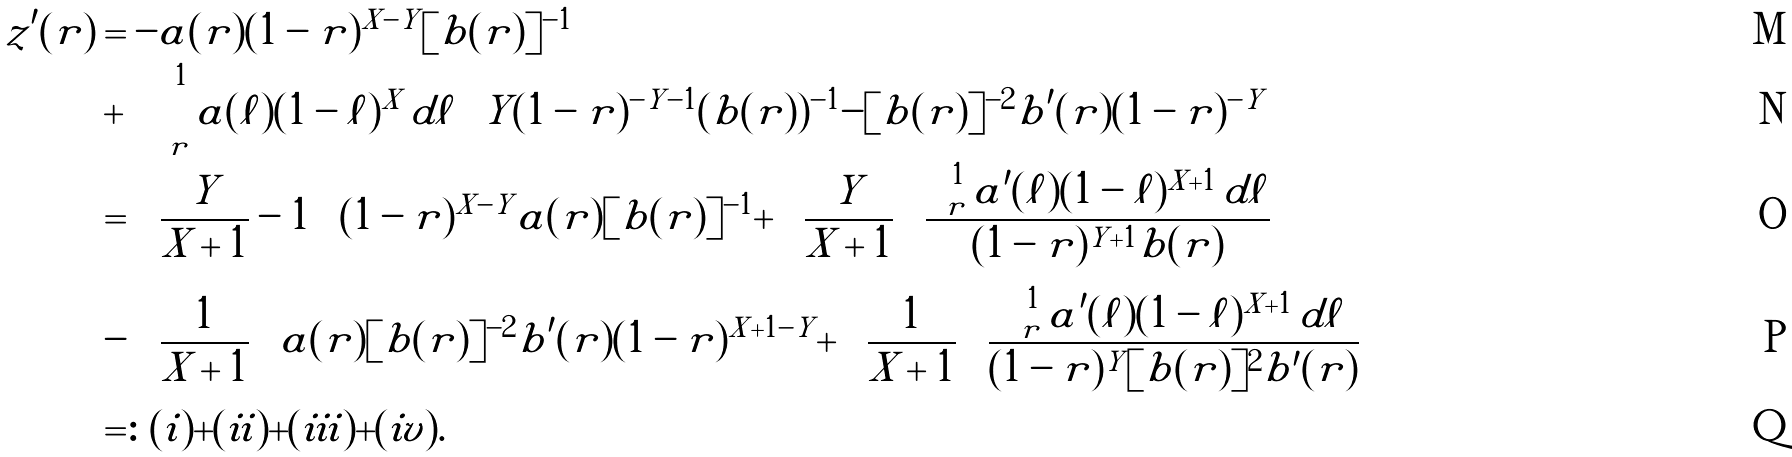<formula> <loc_0><loc_0><loc_500><loc_500>z ^ { \prime } ( r ) & = - a ( r ) ( 1 - r ) ^ { X - Y } [ b ( r ) ] ^ { - 1 } \\ & + \int _ { r } ^ { 1 } a ( \ell ) ( 1 - \ell ) ^ { X } \, d \ell \left [ Y ( 1 - r ) ^ { - Y - 1 } ( b ( r ) ) ^ { - 1 } - [ b ( r ) ] ^ { - 2 } b ^ { \prime } ( r ) ( 1 - r ) ^ { - Y } \right ] \\ & = \left ( \frac { Y } { X + 1 } - 1 \right ) ( 1 - r ) ^ { X - Y } a ( r ) [ b ( r ) ] ^ { - 1 } + \left ( \frac { Y } { X + 1 } \right ) \frac { \int _ { r } ^ { 1 } a ^ { \prime } ( \ell ) ( 1 - \ell ) ^ { X + 1 } \, d \ell } { ( 1 - r ) ^ { Y + 1 } b ( r ) } \\ & - \left ( \frac { 1 } { X + 1 } \right ) a ( r ) [ b ( r ) ] ^ { - 2 } b ^ { \prime } ( r ) ( 1 - r ) ^ { X + 1 - Y } + \left ( \frac { 1 } { X + 1 } \right ) \frac { \int _ { r } ^ { 1 } a ^ { \prime } ( \ell ) ( 1 - \ell ) ^ { X + 1 } \, d \ell } { ( 1 - r ) ^ { Y } [ b ( r ) ] ^ { 2 } b ^ { \prime } ( r ) } \\ & = \colon ( i ) + ( i i ) + ( i i i ) + ( i v ) .</formula> 